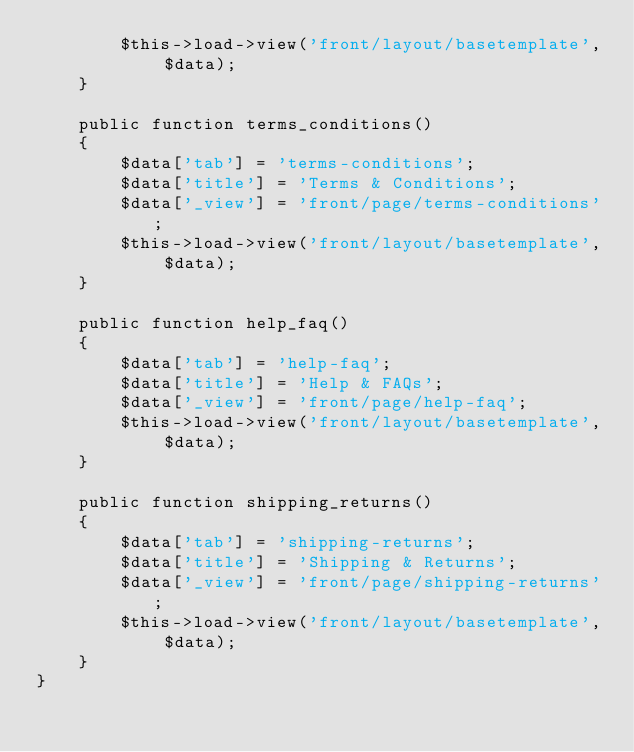<code> <loc_0><loc_0><loc_500><loc_500><_PHP_>        $this->load->view('front/layout/basetemplate', $data);
    }

    public function terms_conditions()
    {
        $data['tab'] = 'terms-conditions';
        $data['title'] = 'Terms & Conditions';
        $data['_view'] = 'front/page/terms-conditions';
        $this->load->view('front/layout/basetemplate', $data);
    }

    public function help_faq()
    {
        $data['tab'] = 'help-faq';
        $data['title'] = 'Help & FAQs';
        $data['_view'] = 'front/page/help-faq';
        $this->load->view('front/layout/basetemplate', $data);
    }

    public function shipping_returns()
    {
        $data['tab'] = 'shipping-returns';
        $data['title'] = 'Shipping & Returns';
        $data['_view'] = 'front/page/shipping-returns';
        $this->load->view('front/layout/basetemplate', $data);
    }
}</code> 